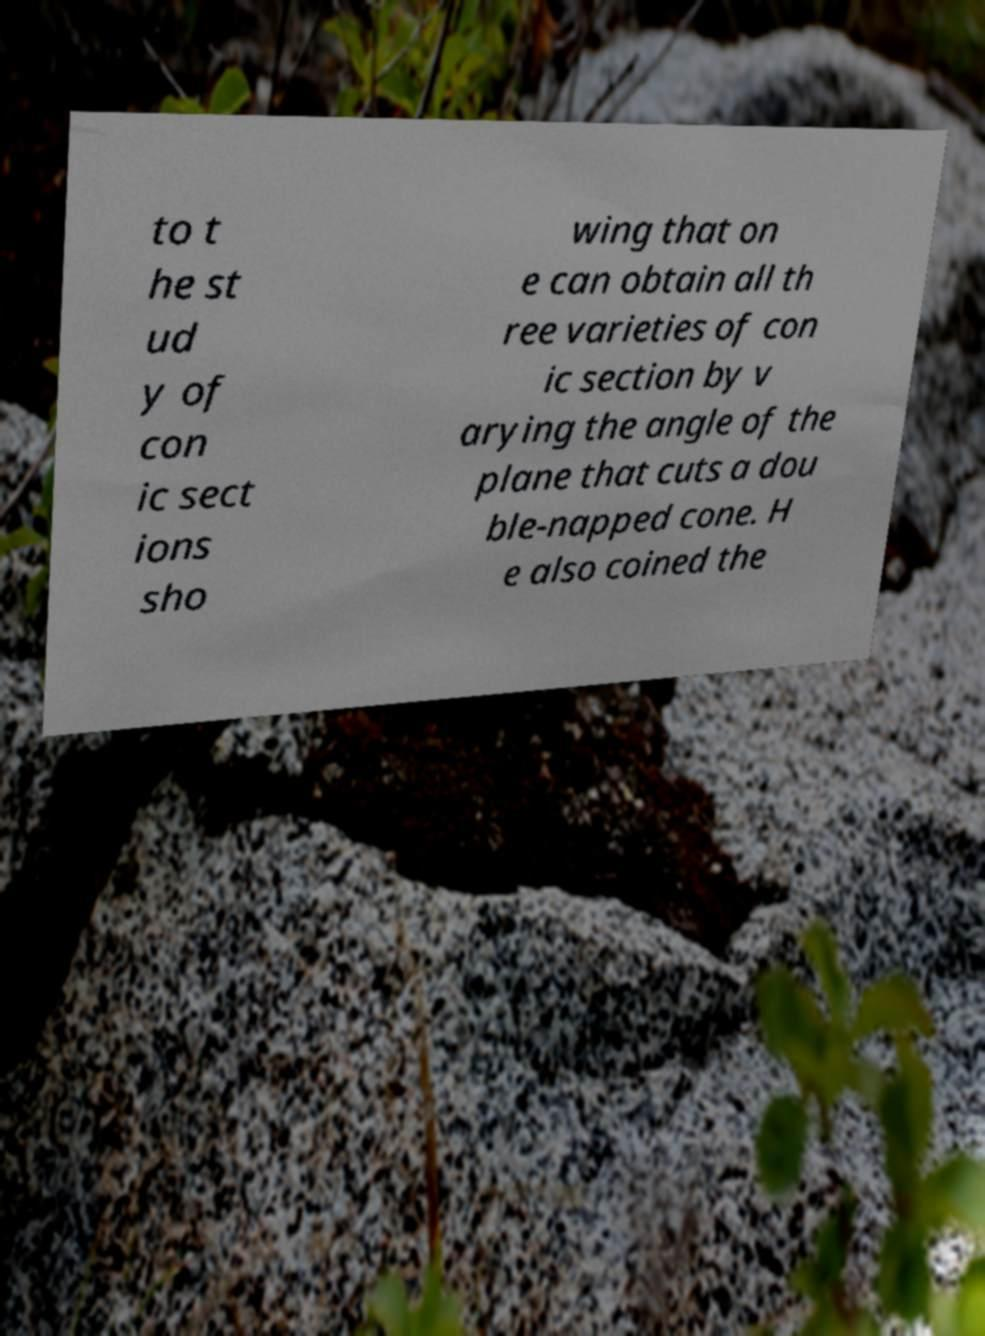Could you assist in decoding the text presented in this image and type it out clearly? to t he st ud y of con ic sect ions sho wing that on e can obtain all th ree varieties of con ic section by v arying the angle of the plane that cuts a dou ble-napped cone. H e also coined the 